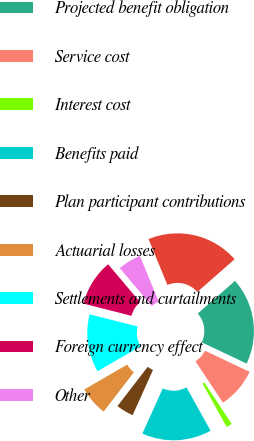<chart> <loc_0><loc_0><loc_500><loc_500><pie_chart><fcel>Years ended December 31<fcel>Projected benefit obligation<fcel>Service cost<fcel>Interest cost<fcel>Benefits paid<fcel>Plan participant contributions<fcel>Actuarial losses<fcel>Settlements and curtailments<fcel>Foreign currency effect<fcel>Other<nl><fcel>19.75%<fcel>18.51%<fcel>8.64%<fcel>1.24%<fcel>14.81%<fcel>3.71%<fcel>6.18%<fcel>12.34%<fcel>9.88%<fcel>4.94%<nl></chart> 